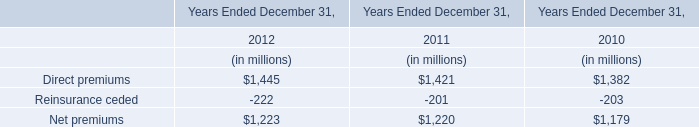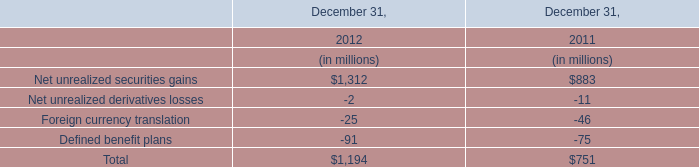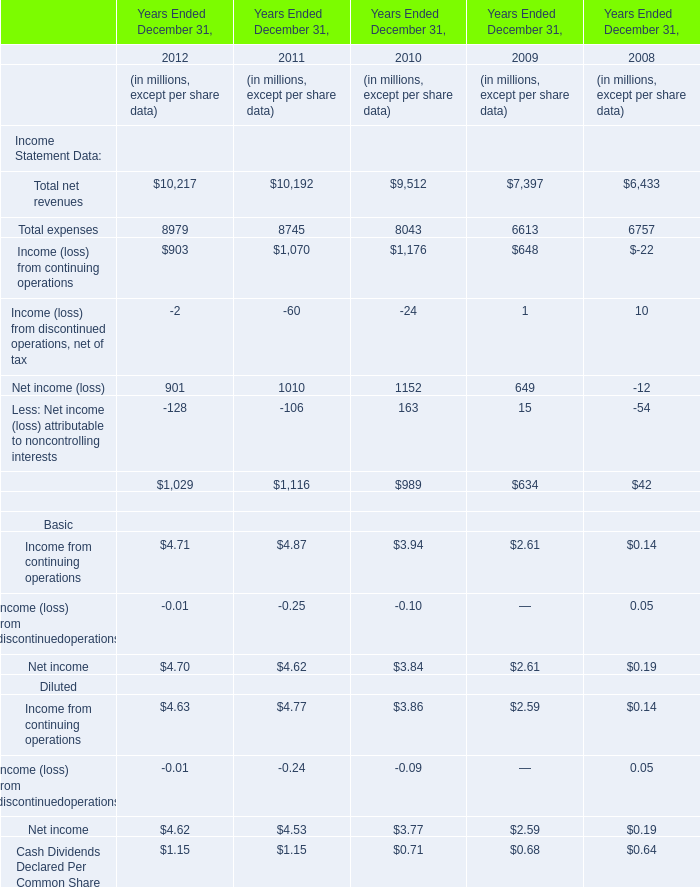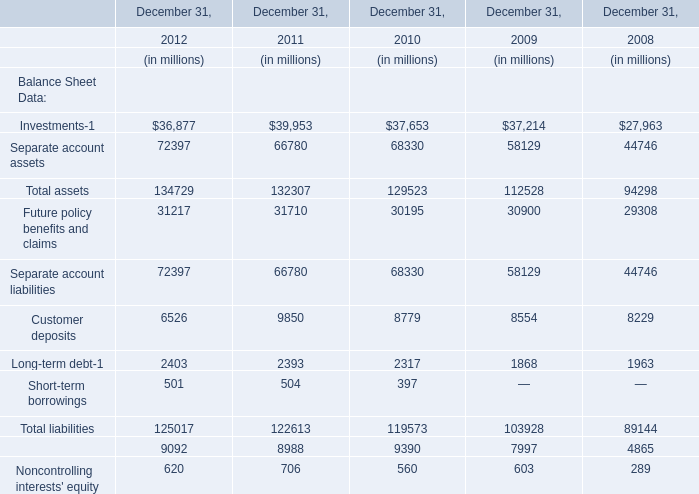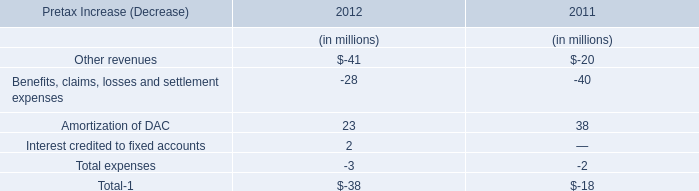In what year is Total assets greater than 134000? 
Answer: 2012. 